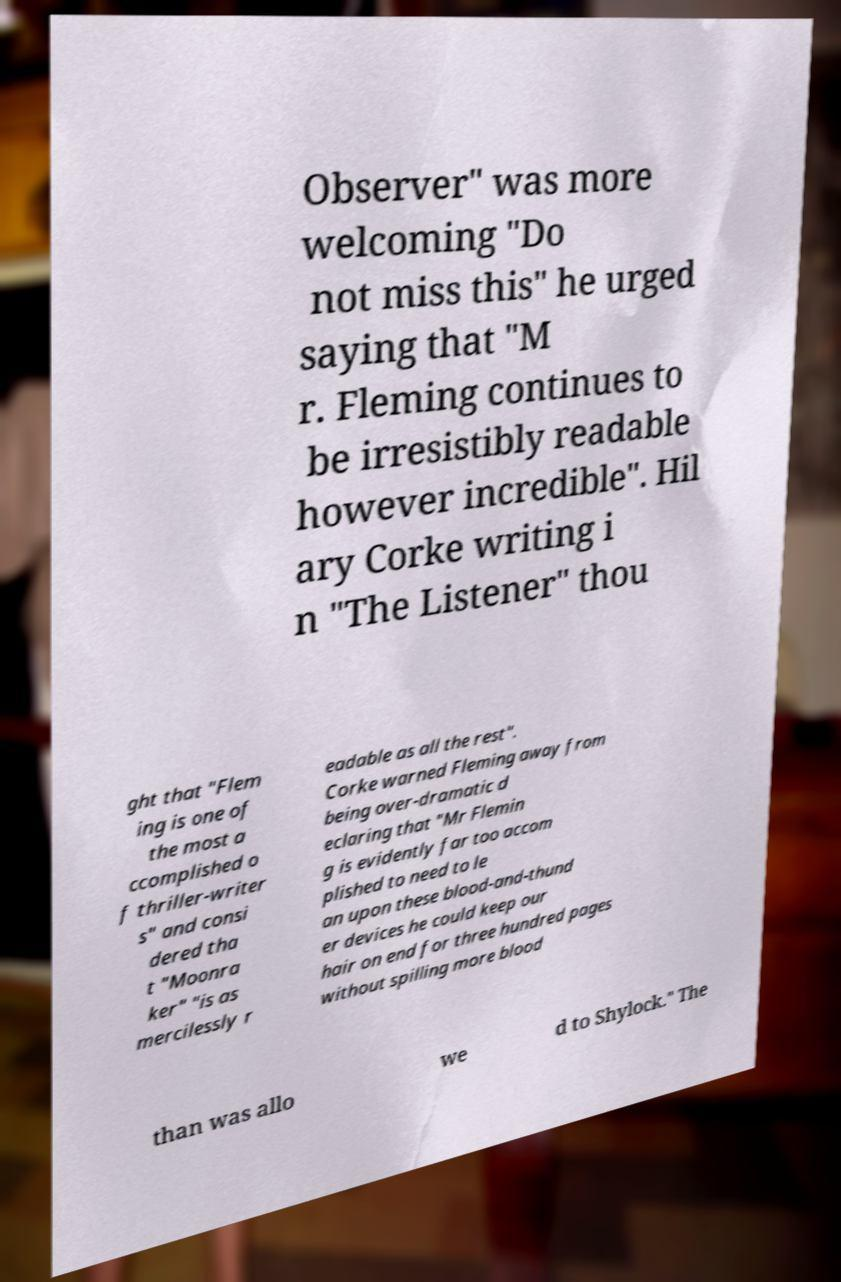There's text embedded in this image that I need extracted. Can you transcribe it verbatim? Observer" was more welcoming "Do not miss this" he urged saying that "M r. Fleming continues to be irresistibly readable however incredible". Hil ary Corke writing i n "The Listener" thou ght that "Flem ing is one of the most a ccomplished o f thriller-writer s" and consi dered tha t "Moonra ker" "is as mercilessly r eadable as all the rest". Corke warned Fleming away from being over-dramatic d eclaring that "Mr Flemin g is evidently far too accom plished to need to le an upon these blood-and-thund er devices he could keep our hair on end for three hundred pages without spilling more blood than was allo we d to Shylock." The 